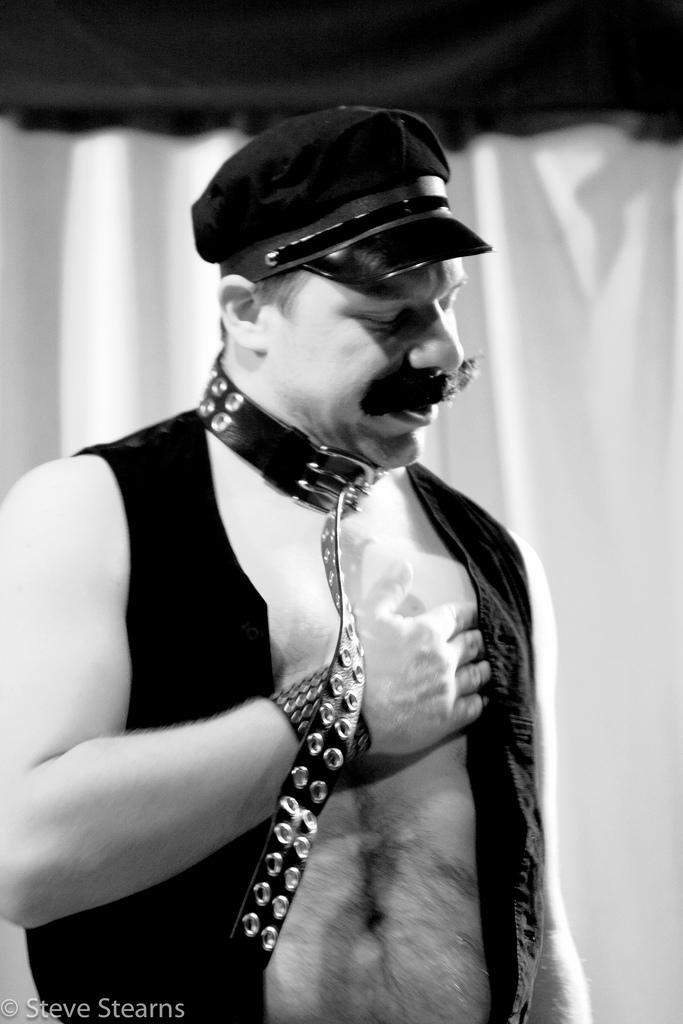What is the color scheme of the image? The image is black and white. Who is present in the image? There is a man in the image. What is the man wearing on his head? The man is wearing a cap. What type of covering can be seen in the image? There is a curtain visible in the image. What type of stamp can be seen on the man's forehead in the image? There is no stamp visible on the man's forehead in the image. What cause does the man in the image support? The image does not provide any information about the man's beliefs or causes he might support. --- Facts: 1. There is a car in the image. 2. The car is red. 3. The car has four wheels. 4. There is a road in the image. 5. The road is paved. Absurd Topics: bird, ocean, mountain Conversation: What is the main subject of the image? The main subject of the image is a car. What color is the car? The car is red. How many wheels does the car have? The car has four wheels. What type of surface can be seen in the image? There is a road in the image, and it is paved. Reasoning: Let's think step by step in order to produce the conversation. We start by identifying the main subject in the image, which is the car. Then, we describe the car's appearance, specifically mentioning its color and the number of wheels. Finally, we mention another object in the image, which is the road, and describe its surface. Each question is designed to elicit a specific detail about the image that is known from the provided facts. Absurd Question/Answer: Can you see any birds flying over the ocean in the image? There is no ocean or birds visible in the image; it features a red car on a paved road. What type of mountain range can be seen in the background of the image? There is no mountain range visible in the image; it features a red car on a paved road. 